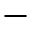<formula> <loc_0><loc_0><loc_500><loc_500>-</formula> 